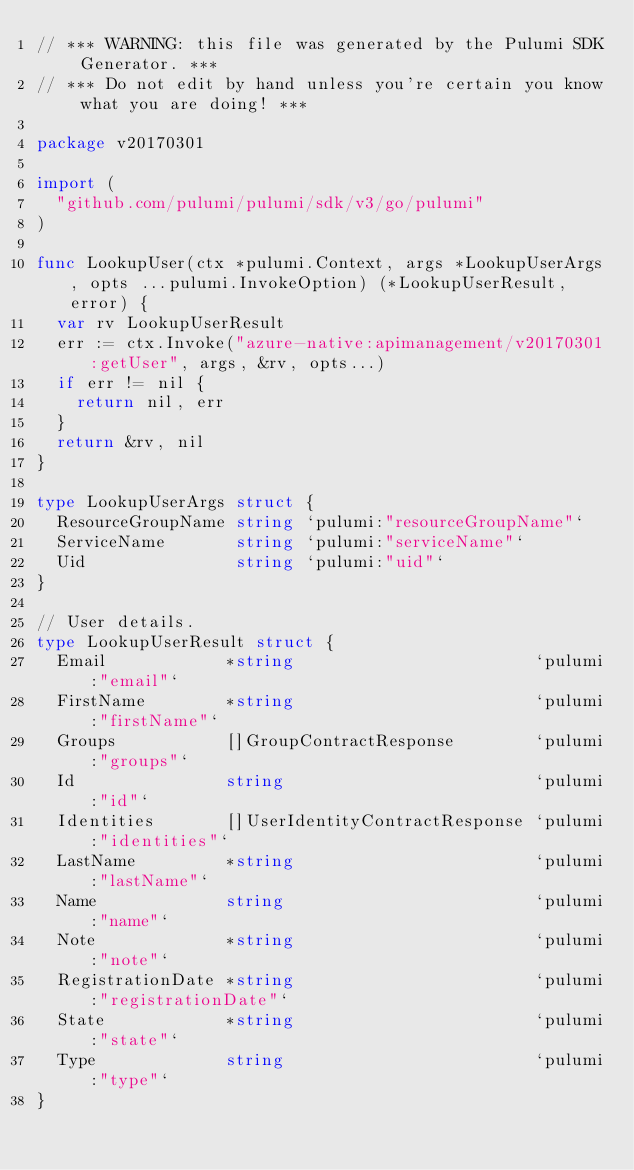Convert code to text. <code><loc_0><loc_0><loc_500><loc_500><_Go_>// *** WARNING: this file was generated by the Pulumi SDK Generator. ***
// *** Do not edit by hand unless you're certain you know what you are doing! ***

package v20170301

import (
	"github.com/pulumi/pulumi/sdk/v3/go/pulumi"
)

func LookupUser(ctx *pulumi.Context, args *LookupUserArgs, opts ...pulumi.InvokeOption) (*LookupUserResult, error) {
	var rv LookupUserResult
	err := ctx.Invoke("azure-native:apimanagement/v20170301:getUser", args, &rv, opts...)
	if err != nil {
		return nil, err
	}
	return &rv, nil
}

type LookupUserArgs struct {
	ResourceGroupName string `pulumi:"resourceGroupName"`
	ServiceName       string `pulumi:"serviceName"`
	Uid               string `pulumi:"uid"`
}

// User details.
type LookupUserResult struct {
	Email            *string                        `pulumi:"email"`
	FirstName        *string                        `pulumi:"firstName"`
	Groups           []GroupContractResponse        `pulumi:"groups"`
	Id               string                         `pulumi:"id"`
	Identities       []UserIdentityContractResponse `pulumi:"identities"`
	LastName         *string                        `pulumi:"lastName"`
	Name             string                         `pulumi:"name"`
	Note             *string                        `pulumi:"note"`
	RegistrationDate *string                        `pulumi:"registrationDate"`
	State            *string                        `pulumi:"state"`
	Type             string                         `pulumi:"type"`
}
</code> 